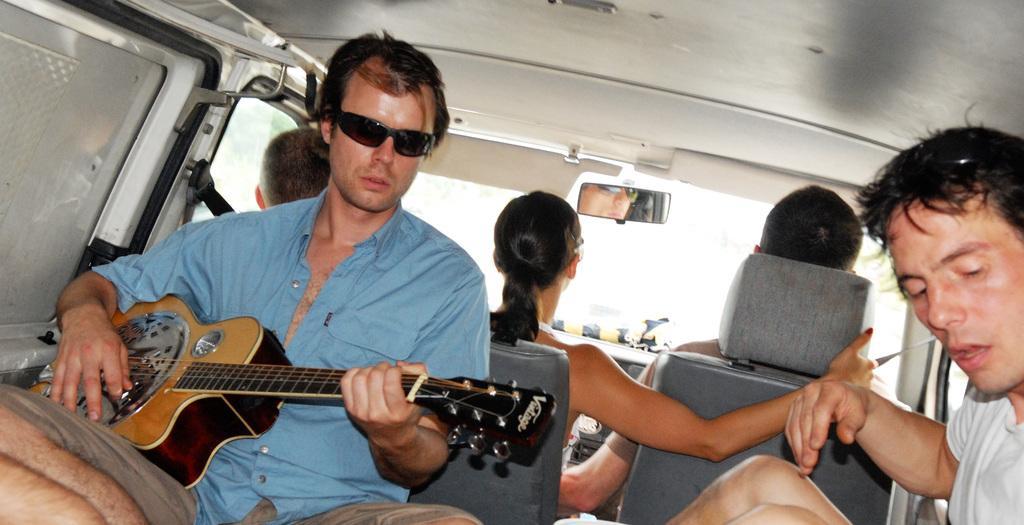How would you summarize this image in a sentence or two? This picture is inside a car. There are five person inside the car. In the left side one person wearing blue shirt and sunglasses is playing guitar. In the front three people are sitting. There is a mirror attached to the car. The person on the right wearing a white t shirt. 